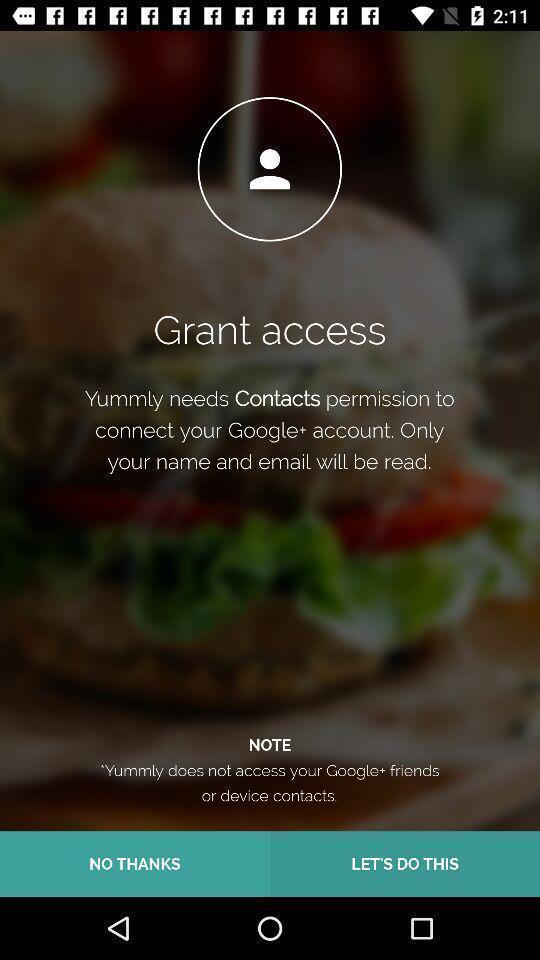Describe the key features of this screenshot. Welcome page of a food application. 